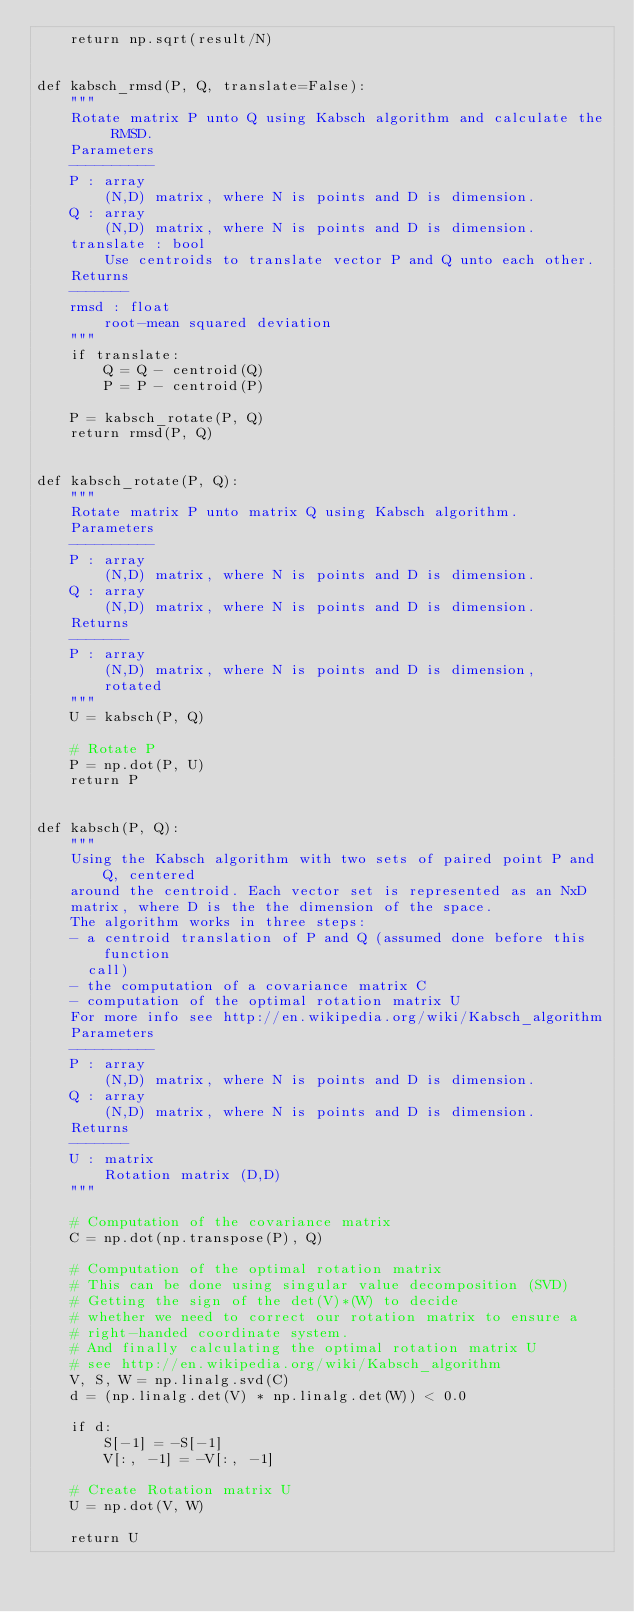<code> <loc_0><loc_0><loc_500><loc_500><_Python_>    return np.sqrt(result/N)


def kabsch_rmsd(P, Q, translate=False):
    """
    Rotate matrix P unto Q using Kabsch algorithm and calculate the RMSD.
    Parameters
    ----------
    P : array
        (N,D) matrix, where N is points and D is dimension.
    Q : array
        (N,D) matrix, where N is points and D is dimension.
    translate : bool
        Use centroids to translate vector P and Q unto each other.
    Returns
    -------
    rmsd : float
        root-mean squared deviation
    """
    if translate:
        Q = Q - centroid(Q)
        P = P - centroid(P)

    P = kabsch_rotate(P, Q)
    return rmsd(P, Q)


def kabsch_rotate(P, Q):
    """
    Rotate matrix P unto matrix Q using Kabsch algorithm.
    Parameters
    ----------
    P : array
        (N,D) matrix, where N is points and D is dimension.
    Q : array
        (N,D) matrix, where N is points and D is dimension.
    Returns
    -------
    P : array
        (N,D) matrix, where N is points and D is dimension,
        rotated
    """
    U = kabsch(P, Q)

    # Rotate P
    P = np.dot(P, U)
    return P


def kabsch(P, Q):
    """
    Using the Kabsch algorithm with two sets of paired point P and Q, centered
    around the centroid. Each vector set is represented as an NxD
    matrix, where D is the the dimension of the space.
    The algorithm works in three steps:
    - a centroid translation of P and Q (assumed done before this function
      call)
    - the computation of a covariance matrix C
    - computation of the optimal rotation matrix U
    For more info see http://en.wikipedia.org/wiki/Kabsch_algorithm
    Parameters
    ----------
    P : array
        (N,D) matrix, where N is points and D is dimension.
    Q : array
        (N,D) matrix, where N is points and D is dimension.
    Returns
    -------
    U : matrix
        Rotation matrix (D,D)
    """

    # Computation of the covariance matrix
    C = np.dot(np.transpose(P), Q)

    # Computation of the optimal rotation matrix
    # This can be done using singular value decomposition (SVD)
    # Getting the sign of the det(V)*(W) to decide
    # whether we need to correct our rotation matrix to ensure a
    # right-handed coordinate system.
    # And finally calculating the optimal rotation matrix U
    # see http://en.wikipedia.org/wiki/Kabsch_algorithm
    V, S, W = np.linalg.svd(C)
    d = (np.linalg.det(V) * np.linalg.det(W)) < 0.0

    if d:
        S[-1] = -S[-1]
        V[:, -1] = -V[:, -1]

    # Create Rotation matrix U
    U = np.dot(V, W)

    return U
</code> 